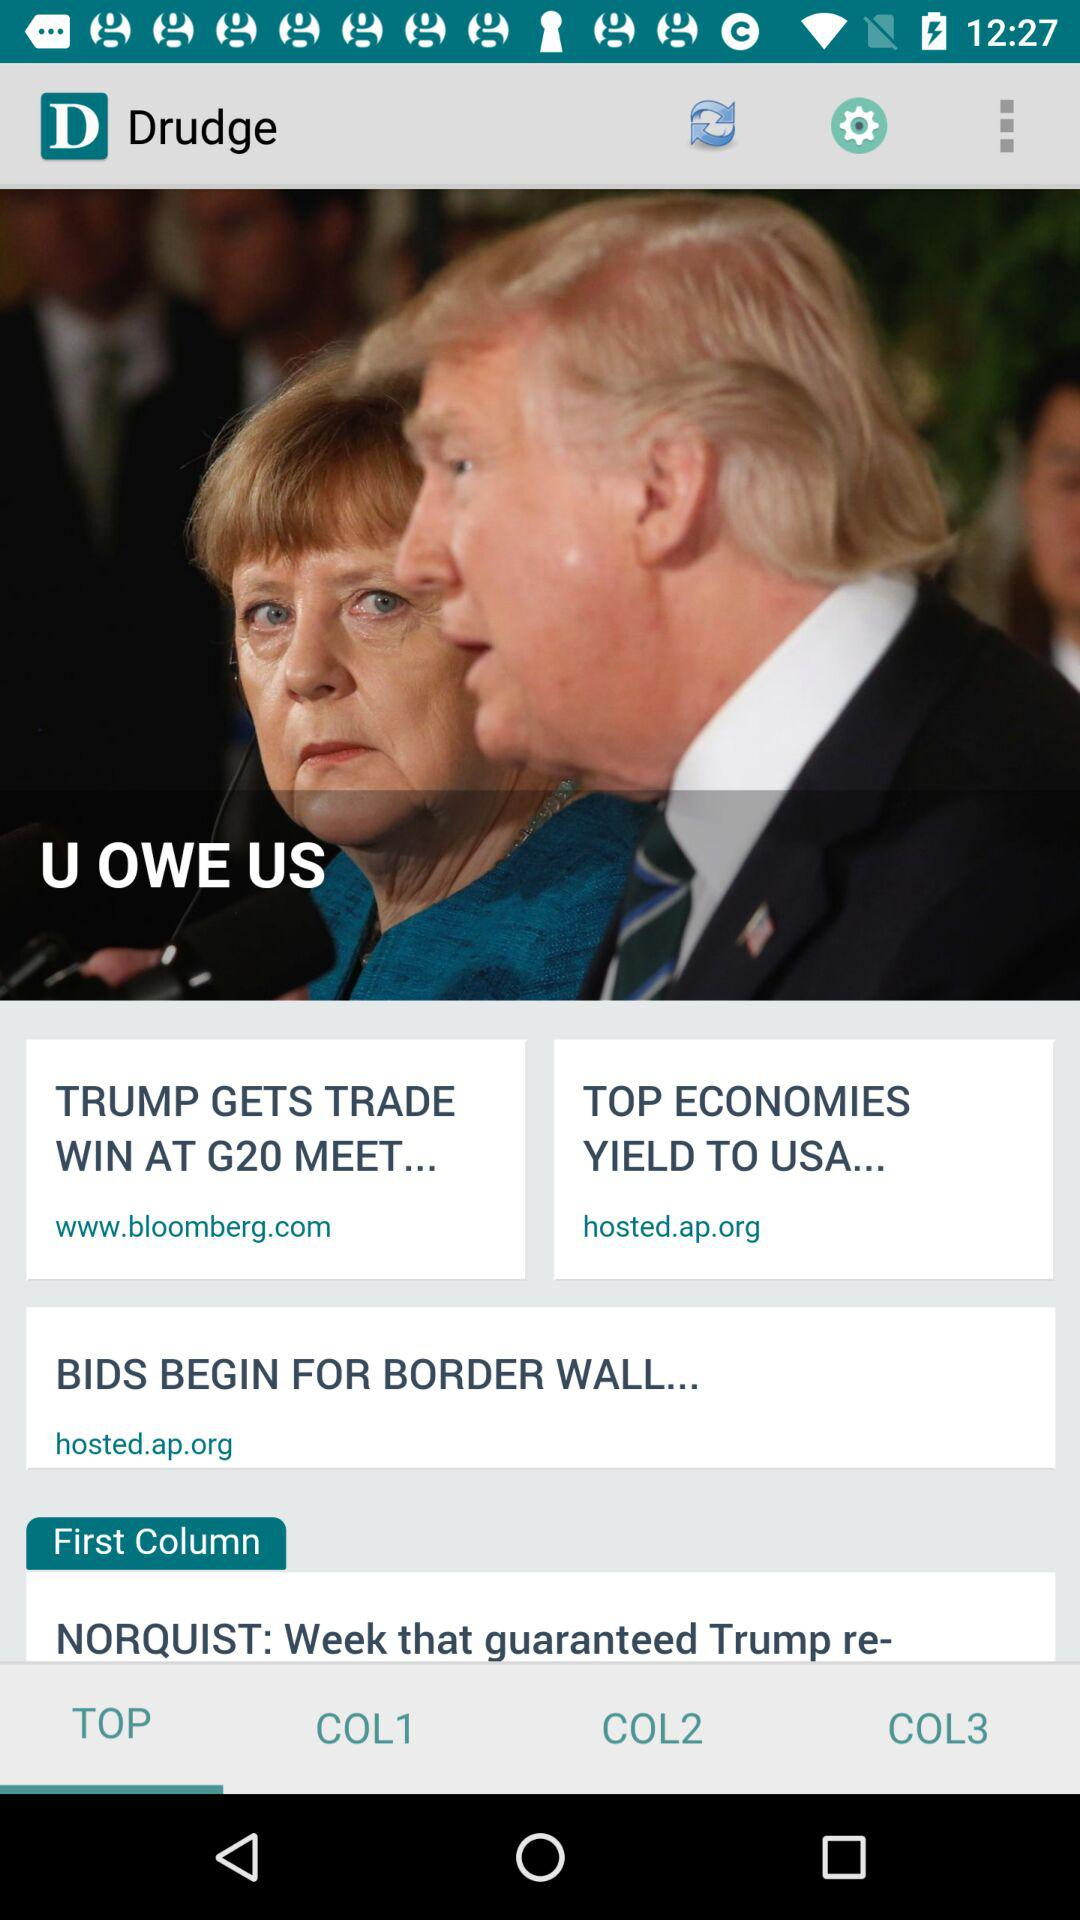What is the headline of the report? The headline of the report is "U OWE US". 